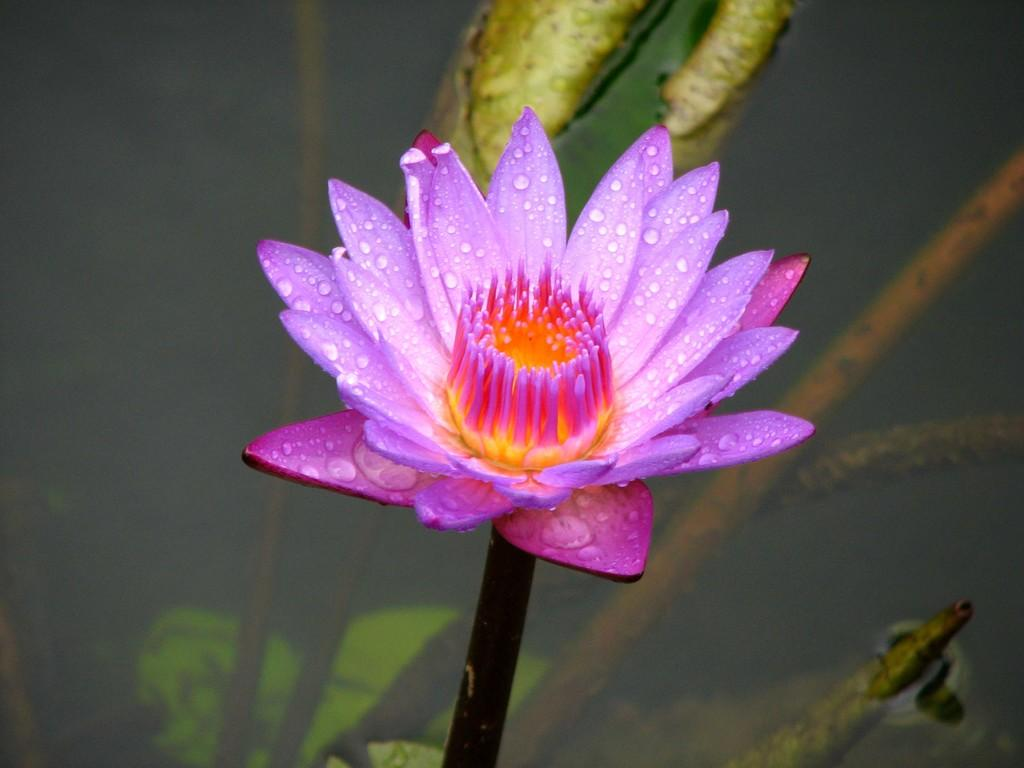What type of plant is featured in the picture? There is a lotus in the picture. What other plants can be seen in the picture? There are water plants in the picture. What is the primary setting for the plants in the picture? There is water visible in the picture. What is the condition of the lotus in the picture? There are water droplets on the lotus. What color is the lotus in the picture? The lotus is purple in color. Is the lotus being used as a steering wheel while driving in the picture? No, the lotus is not being used as a steering wheel, and there is no driving depicted in the image. 